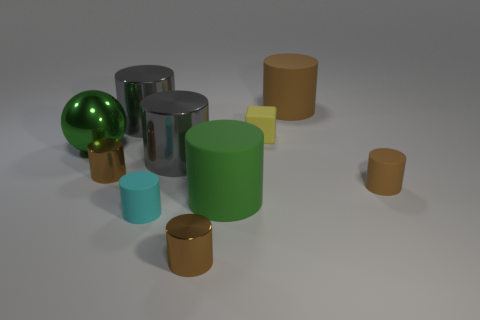Are there any big cylinders of the same color as the large sphere?
Keep it short and to the point. Yes. What is the size of the matte cylinder that is the same color as the ball?
Your response must be concise. Large. There is a brown thing that is the same size as the green cylinder; what shape is it?
Give a very brief answer. Cylinder. Is there any other thing that has the same size as the green sphere?
Your answer should be very brief. Yes. There is a brown metal cylinder that is behind the green rubber thing; is it the same size as the gray cylinder in front of the tiny yellow rubber cube?
Keep it short and to the point. No. How big is the brown matte cylinder that is behind the tiny brown matte cylinder?
Ensure brevity in your answer.  Large. What material is the large thing that is the same color as the sphere?
Give a very brief answer. Rubber. What is the color of the block that is the same size as the cyan cylinder?
Provide a succinct answer. Yellow. Does the green matte object have the same size as the sphere?
Give a very brief answer. Yes. There is a cylinder that is both left of the small cyan thing and behind the small yellow rubber block; what size is it?
Your answer should be compact. Large. 